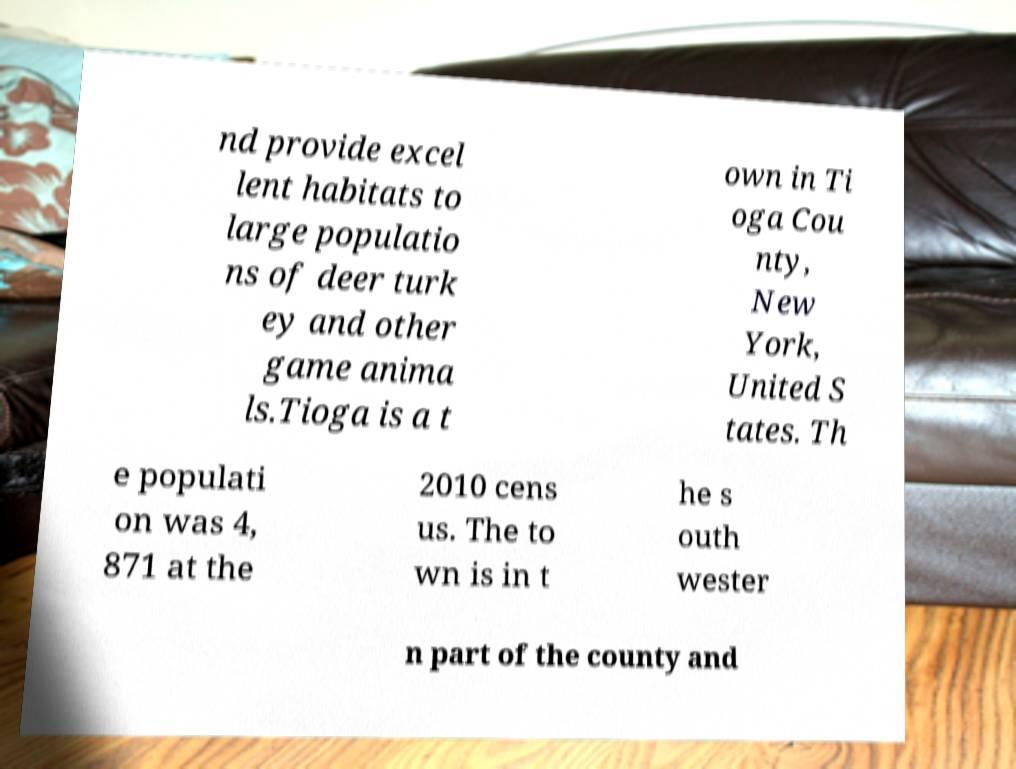Please read and relay the text visible in this image. What does it say? nd provide excel lent habitats to large populatio ns of deer turk ey and other game anima ls.Tioga is a t own in Ti oga Cou nty, New York, United S tates. Th e populati on was 4, 871 at the 2010 cens us. The to wn is in t he s outh wester n part of the county and 